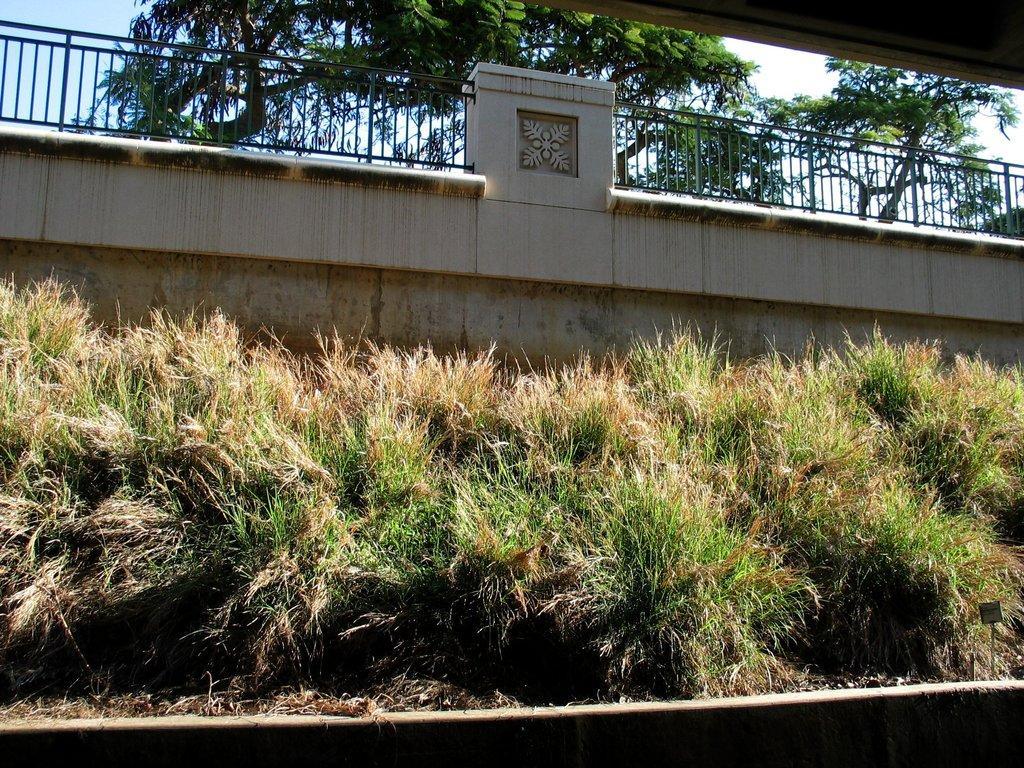How would you summarize this image in a sentence or two? In the picture we can see grass plants near the wall and to the wall we can see railing and behind it, we can see trees and part of the sky. 